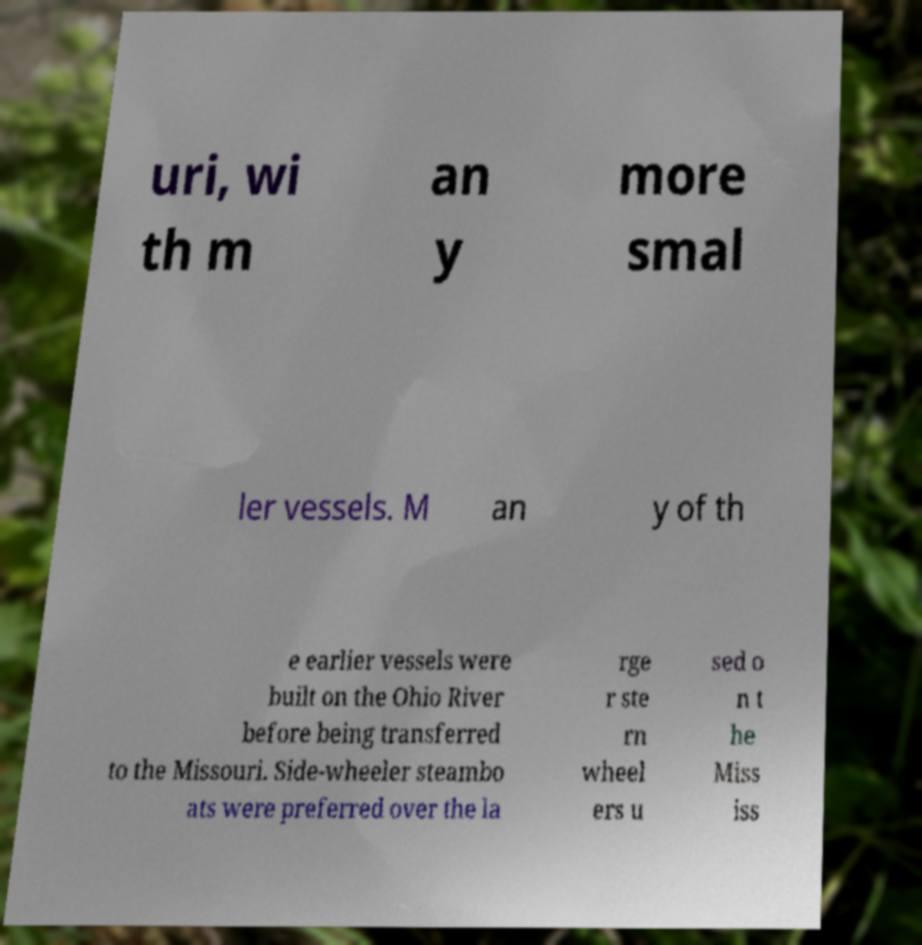There's text embedded in this image that I need extracted. Can you transcribe it verbatim? uri, wi th m an y more smal ler vessels. M an y of th e earlier vessels were built on the Ohio River before being transferred to the Missouri. Side-wheeler steambo ats were preferred over the la rge r ste rn wheel ers u sed o n t he Miss iss 